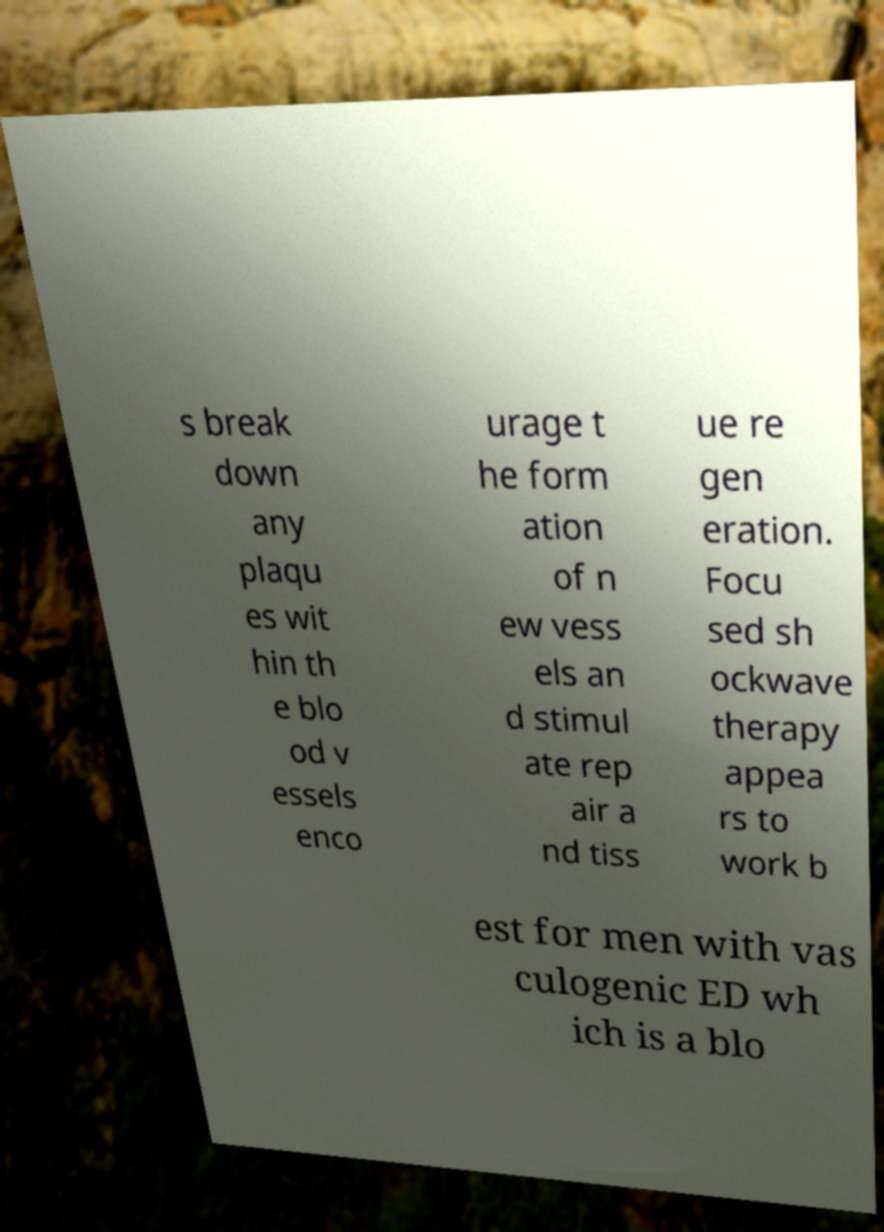Can you accurately transcribe the text from the provided image for me? s break down any plaqu es wit hin th e blo od v essels enco urage t he form ation of n ew vess els an d stimul ate rep air a nd tiss ue re gen eration. Focu sed sh ockwave therapy appea rs to work b est for men with vas culogenic ED wh ich is a blo 